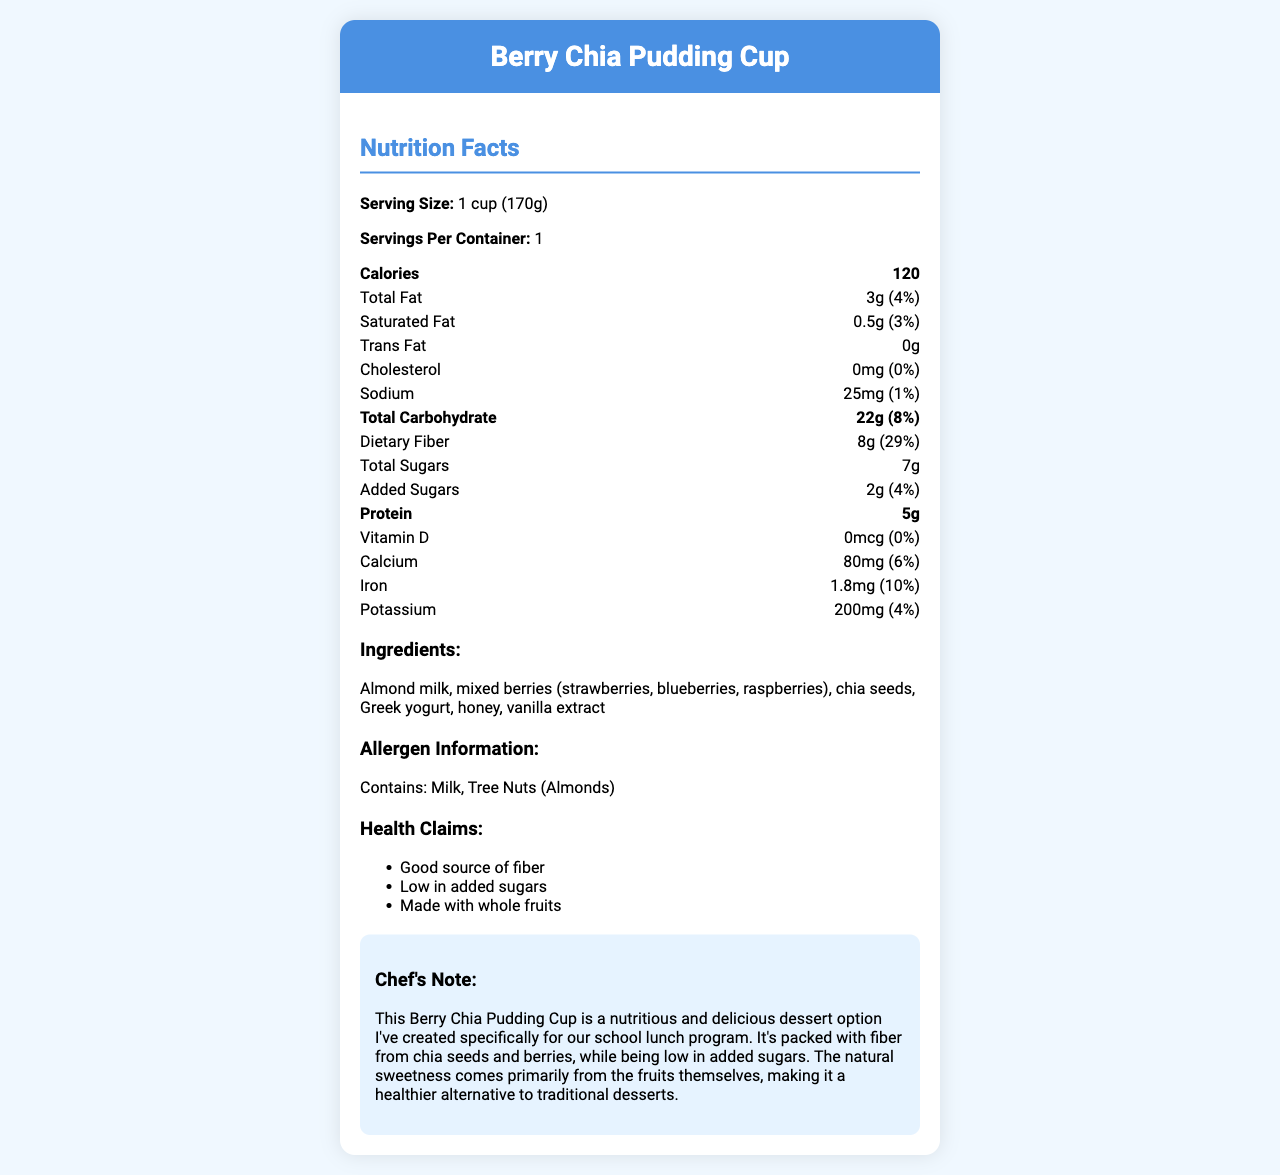what is the serving size? The serving size is stated directly under the "Nutrition Facts" heading as "Serving Size: 1 cup (170g)".
Answer: 1 cup (170g) what are the main ingredients in this fruit-based dessert? The ingredients are listed clearly in the ingredients section of the label.
Answer: Almond milk, mixed berries, chia seeds, Greek yogurt, honey, vanilla extract how many grams of dietary fiber are there per serving? The dietary fiber amount is listed under the "Total Carbohydrate" section as "Dietary Fiber: 8g".
Answer: 8g how many calories come from fat? The nutrition facts provide the total fat amount and calories, but do not break down the calories specifically from fat.
Answer: Cannot be determined what allergens are present in the Berry Chia Pudding Cup? The allergen information section mentions "Contains: Milk, Tree Nuts (Almonds)".
Answer: Milk, Tree Nuts (Almonds) what is the total amount of carbohydrates in this dessert? The total carbohydrate amount is stated as "Total Carbohydrate: 22g (8%)".
Answer: 22g is this dessert low in sodium? (Yes/No) The sodium content is low at 25mg, which is 1% of the daily value, indicating that it fits within low-sodium guidelines.
Answer: Yes which vitamin is present in the least amount in this dessert? A. Vitamin D B. Calcium C. Iron D. Potassium Vitamin D is listed as 0mcg (0% daily value), making it the vitamin present in the least amount.
Answer: A which statement is correct about the health claims? A. High in protein B. Low in added sugars C. Gluten-free D. Contains artificial sweeteners One of the health claims mentioned is "Low in added sugars".
Answer: B what is the main idea of the chef's note? The chef's note explains that the dessert is designed to be healthy with natural sweetness from fruits and high fiber content.
Answer: The dessert is nutritious, packed with fiber, low in added sugars, and primarily sweetened by natural fruit. how much protein does the Berry Chia Pudding Cup provide per serving? The protein content is clearly listed as "Protein: 5g".
Answer: 5g how does this dessert support a healthy diet for school children? The health claims highlight the dessert's nutritional benefits and low sugar content, making it suitable for a school lunch program.
Answer: It's a good source of fiber, low in added sugars, and contains whole fruits. what percentage of daily value for iron is provided by one serving? The iron content is listed as 1.8mg, which corresponds to 10% of the daily value.
Answer: 10% what sweeteners are used in this dessert? The ingredients list includes honey as the sweetener used in this dessert.
Answer: Honey does the Berry Chia Pudding Cup contain any trans fat? (True/False) The nutrition facts state "Trans Fat: 0g" meaning there is no trans fat present.
Answer: False 